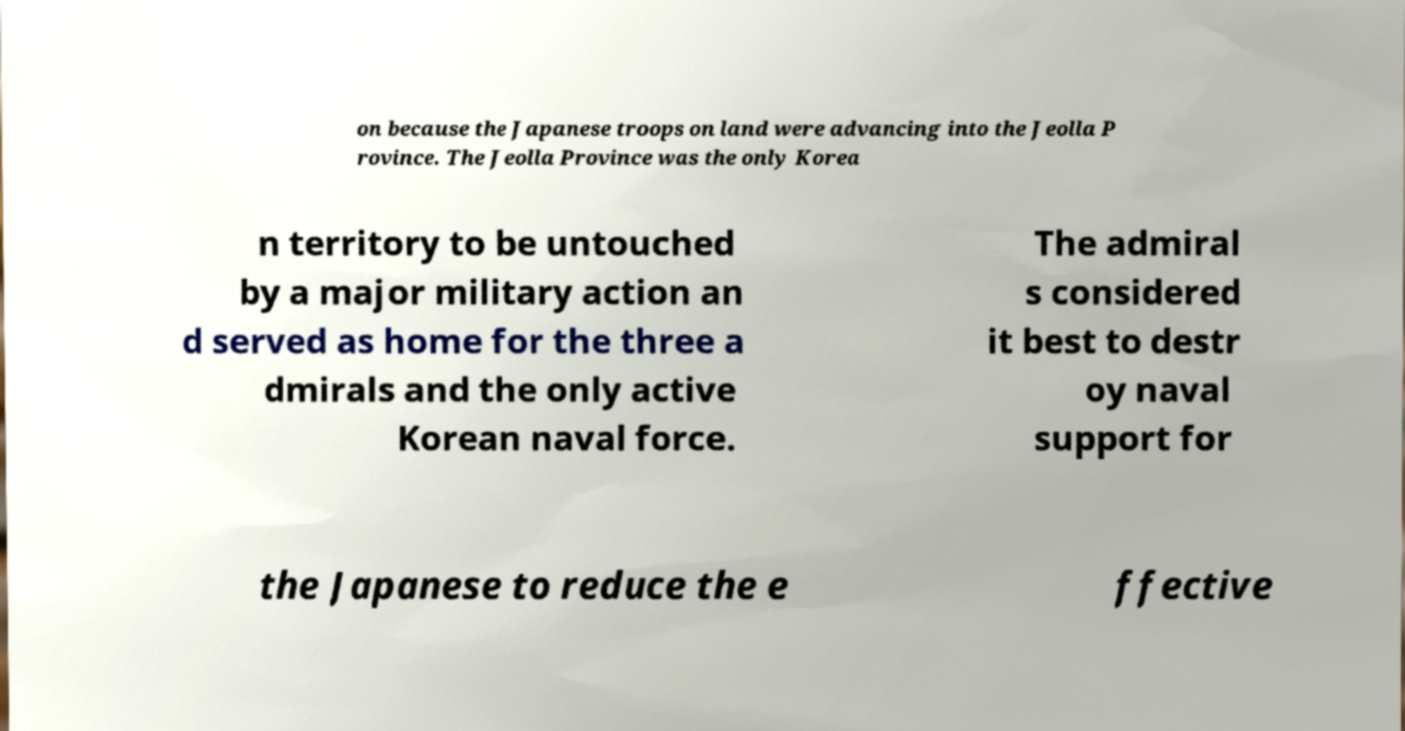What messages or text are displayed in this image? I need them in a readable, typed format. on because the Japanese troops on land were advancing into the Jeolla P rovince. The Jeolla Province was the only Korea n territory to be untouched by a major military action an d served as home for the three a dmirals and the only active Korean naval force. The admiral s considered it best to destr oy naval support for the Japanese to reduce the e ffective 